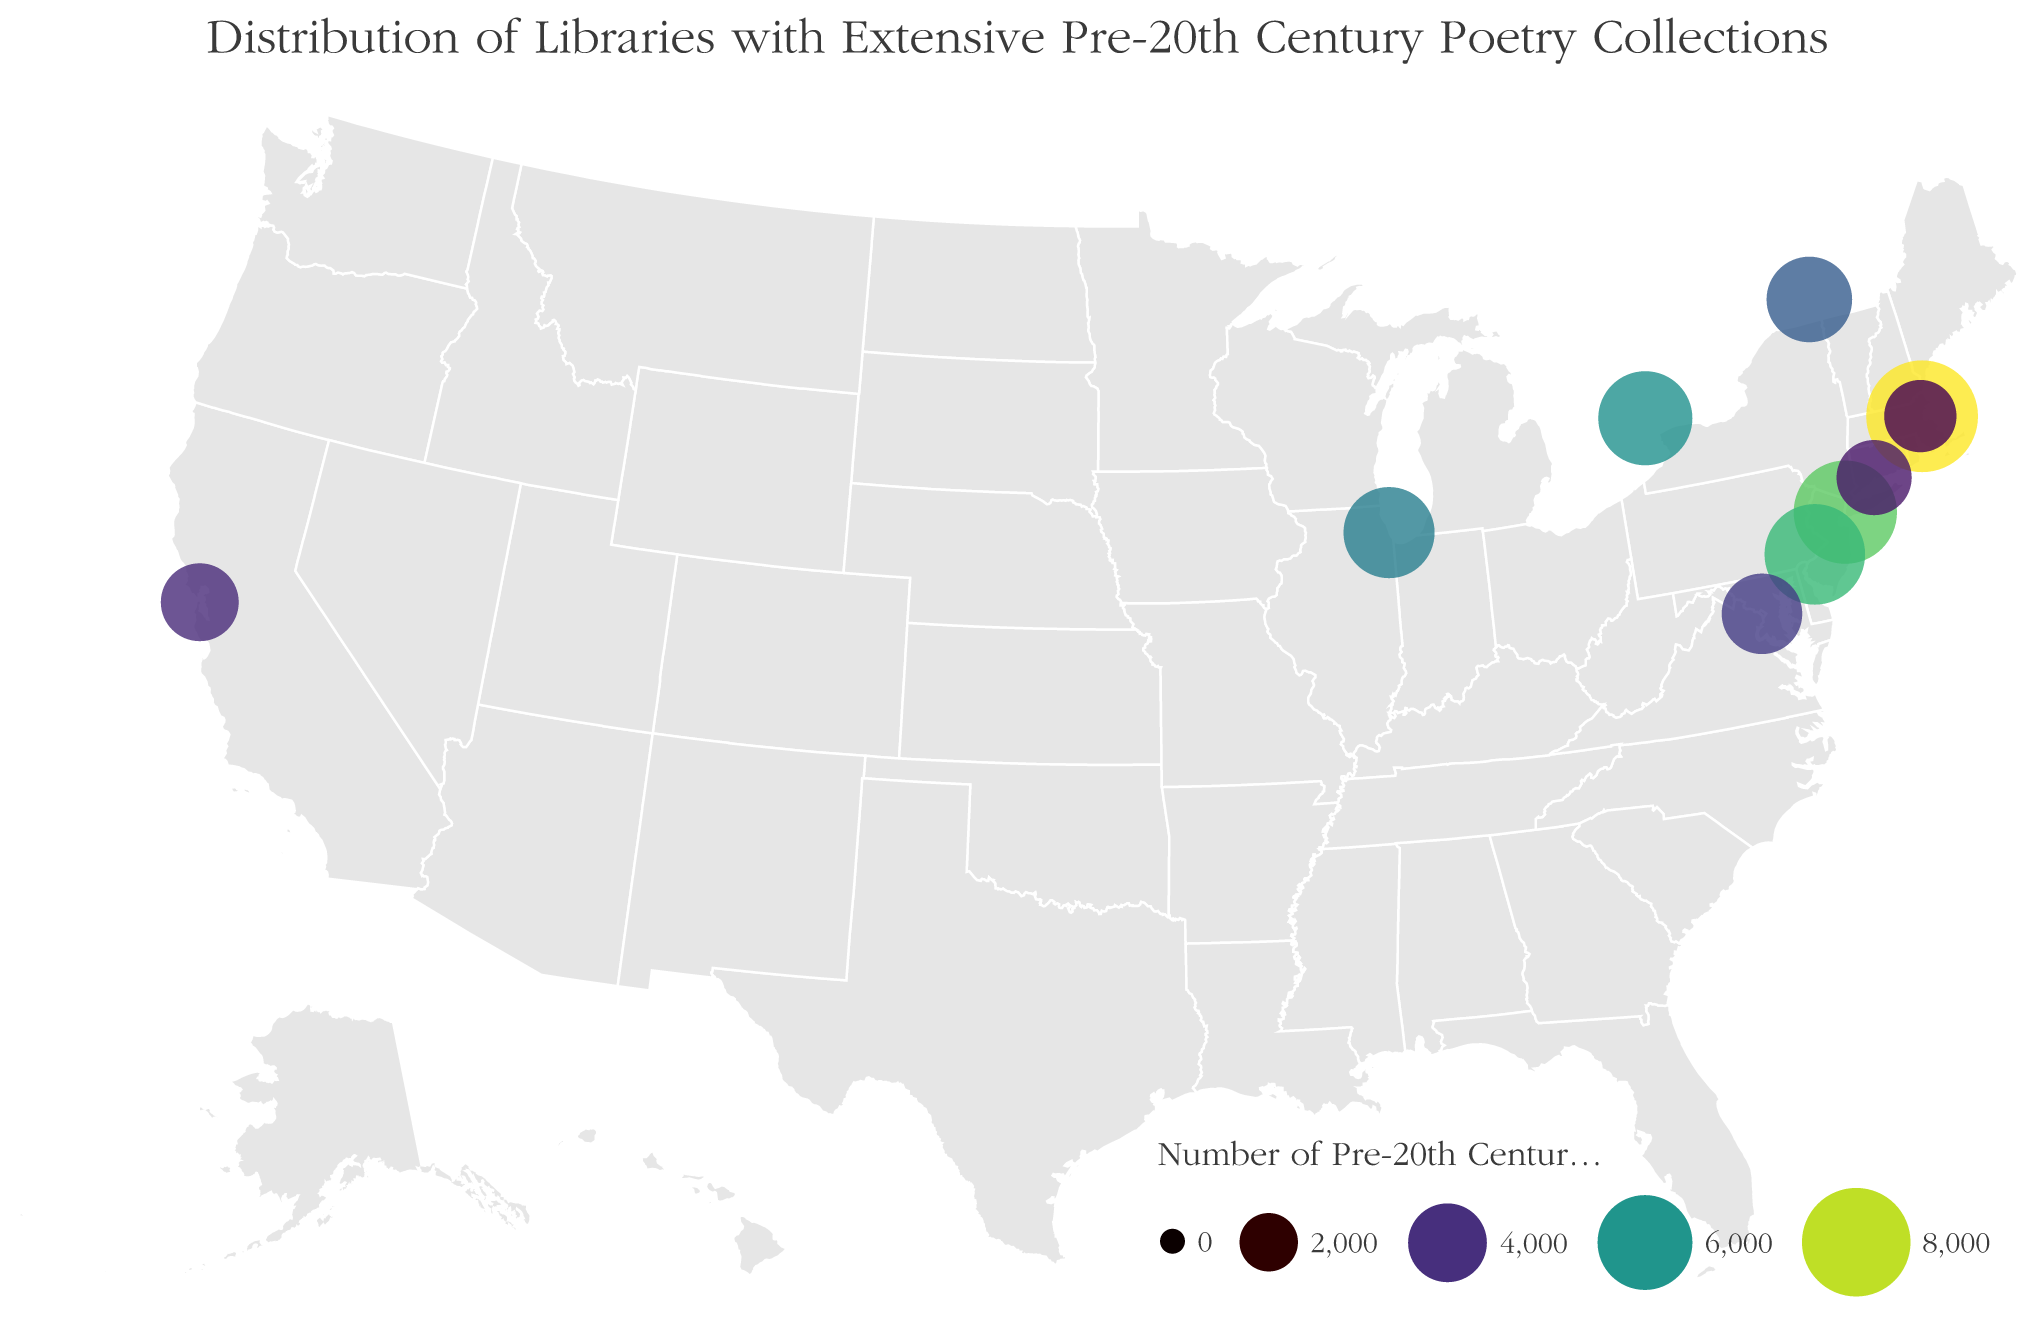What does the title of the figure say? The title is usually at the top of the figure and gives an overview of what the figure is about.
Answer: "Distribution of Libraries with Extensive Pre-20th Century Poetry Collections" Which city has the largest number of pre-20th century poetry anthologies? Look for the city with the largest circle, as size represents the number of anthologies.
Answer: Boston How many libraries in North America hold more than 5,000 pre-20th century poetry anthologies? Count the circles whose size indicates more than 5,000 anthologies based on their relative size or tooltip information.
Answer: 4 Which two cities in Canada are represented in the figure? Identify cities labeled as being in Canadian provinces (Ontario and Quebec).
Answer: Toronto and Montreal What is the total number of pre-20th century poetry anthologies in New York City and Philadelphia combined? Sum the number of anthologies for New York City (7,200) and Philadelphia (6,800).
Answer: 14,000 Which cities have fewer than 4,000 pre-20th century poetry anthologies? Identify and list the cities with circles that are smaller, and check their tooltip information.
Answer: San Francisco, New Haven, Cambridge What is the average number of pre-20th century poetry anthologies in the top three cities? Find the top three cities (Boston, New York City, Philadelphia), sum their anthology numbers (8,500 + 7,200 + 6,800), and divide by 3.
Answer: 7,500 Which city is located farthest to the west? Identify the city with the westernmost longitude.
Answer: San Francisco Are there more libraries with extensive pre-20th century poetry collections in the USA or Canada based on this figure? Count the number of libraries in the USA and Canada, then compare. USA has Boston, New York City, Philadelphia, Chicago, Washington D.C., San Francisco, New Haven, and Cambridge. Canada has Toronto and Montreal.
Answer: USA Which cities are located in Massachusetts? Identify cities in the figure labeled as being in Massachusetts.
Answer: Boston and Cambridge 